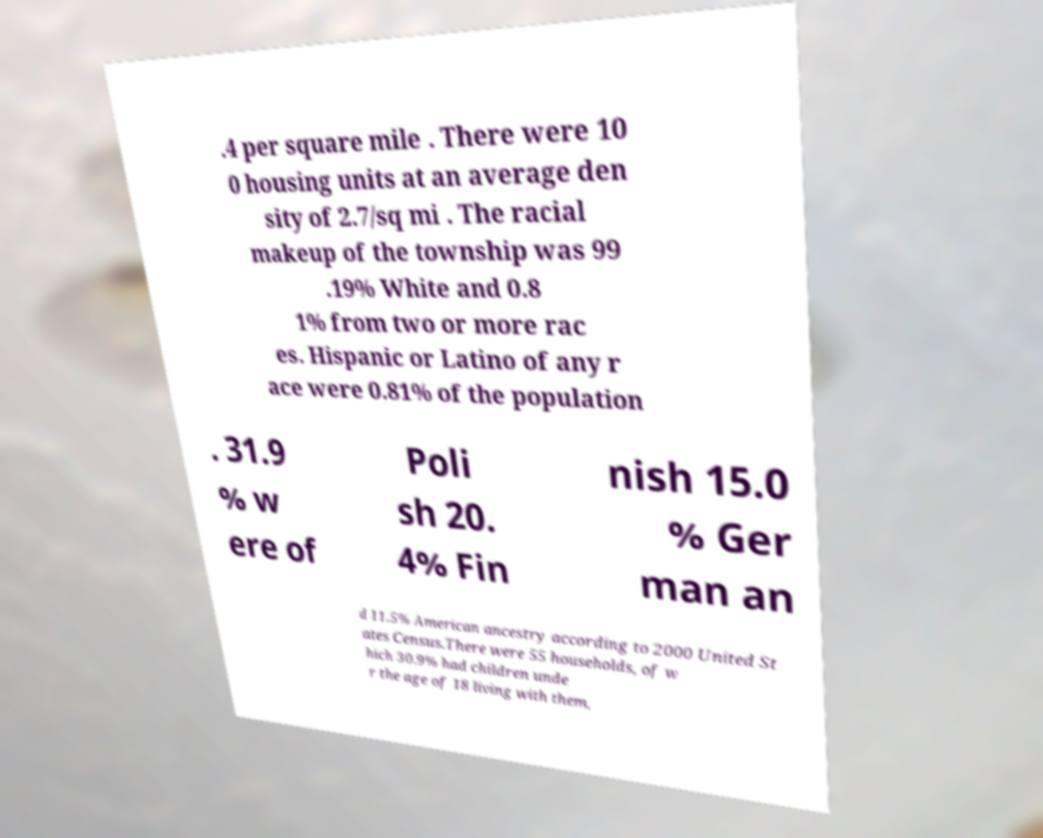I need the written content from this picture converted into text. Can you do that? .4 per square mile . There were 10 0 housing units at an average den sity of 2.7/sq mi . The racial makeup of the township was 99 .19% White and 0.8 1% from two or more rac es. Hispanic or Latino of any r ace were 0.81% of the population . 31.9 % w ere of Poli sh 20. 4% Fin nish 15.0 % Ger man an d 11.5% American ancestry according to 2000 United St ates Census.There were 55 households, of w hich 30.9% had children unde r the age of 18 living with them, 